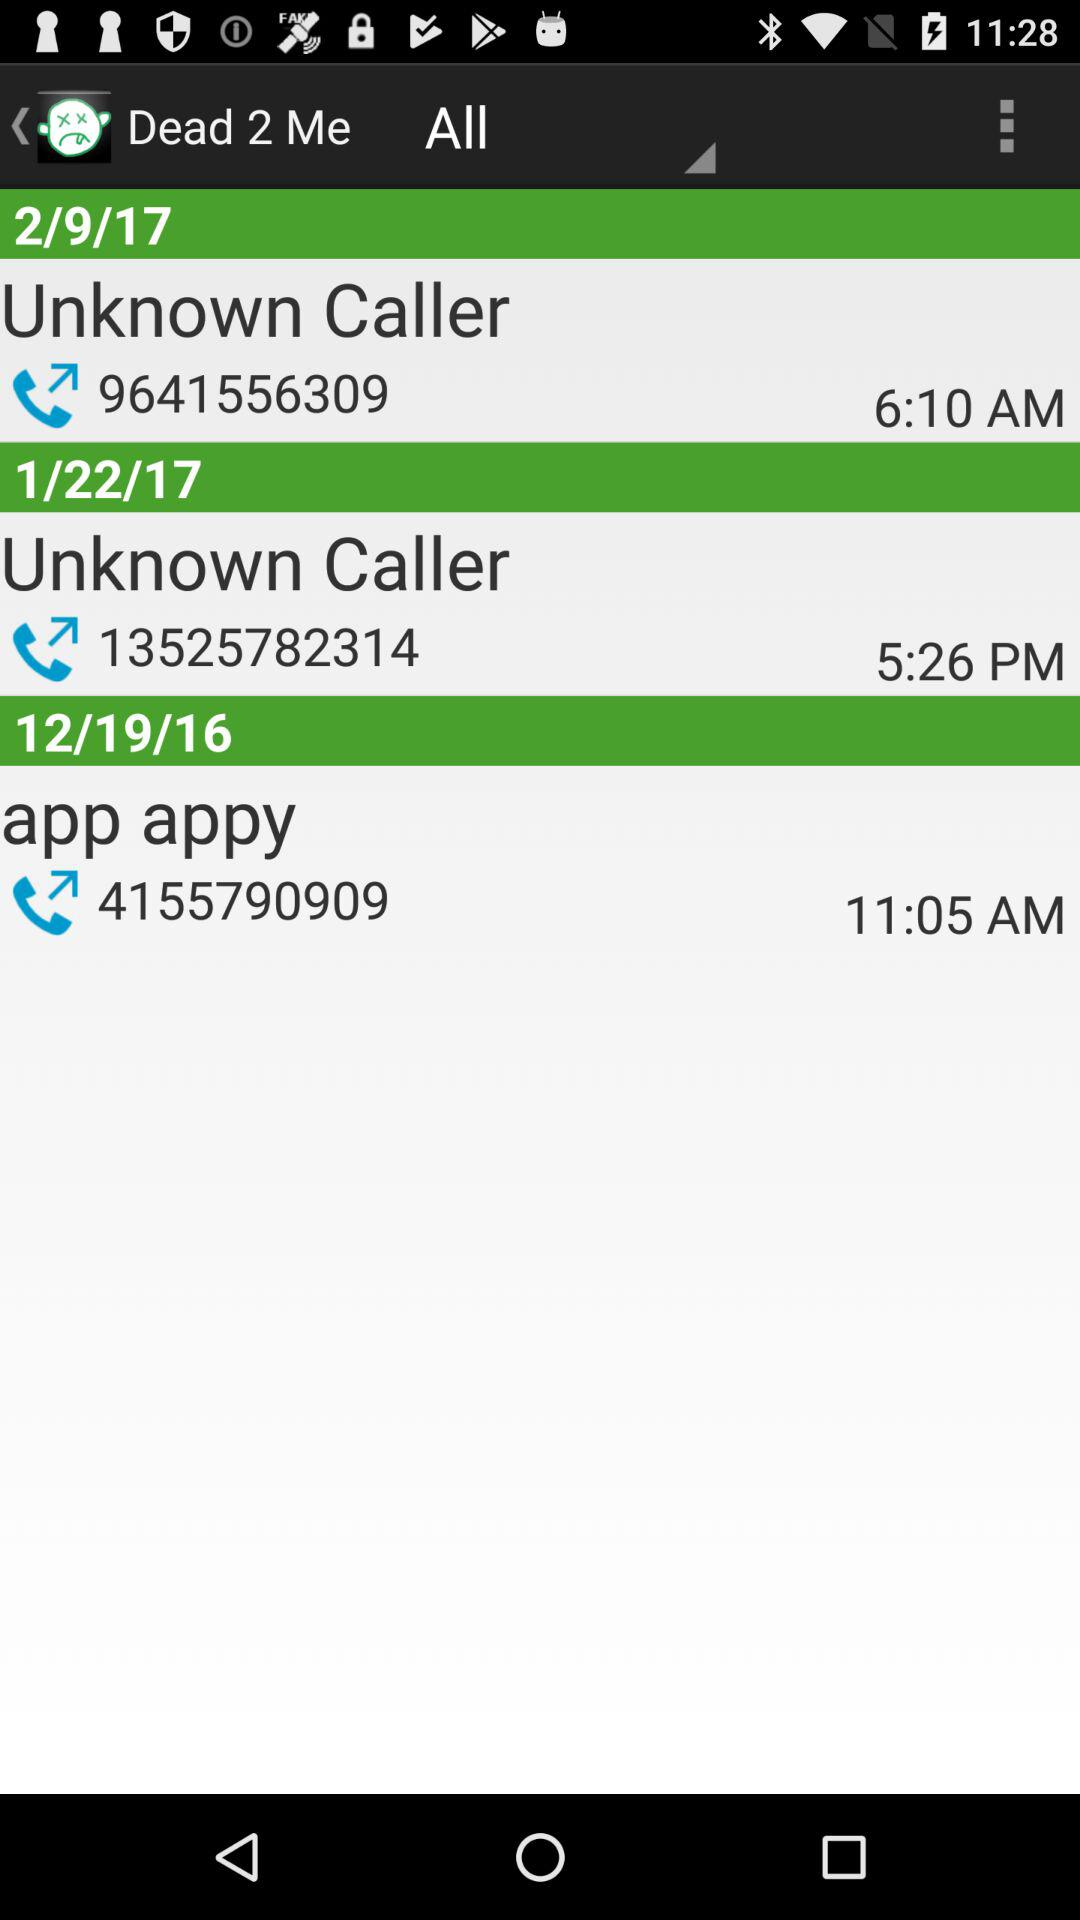What time was the call made on 1/22/17? The call was made at 5:26 PM. 